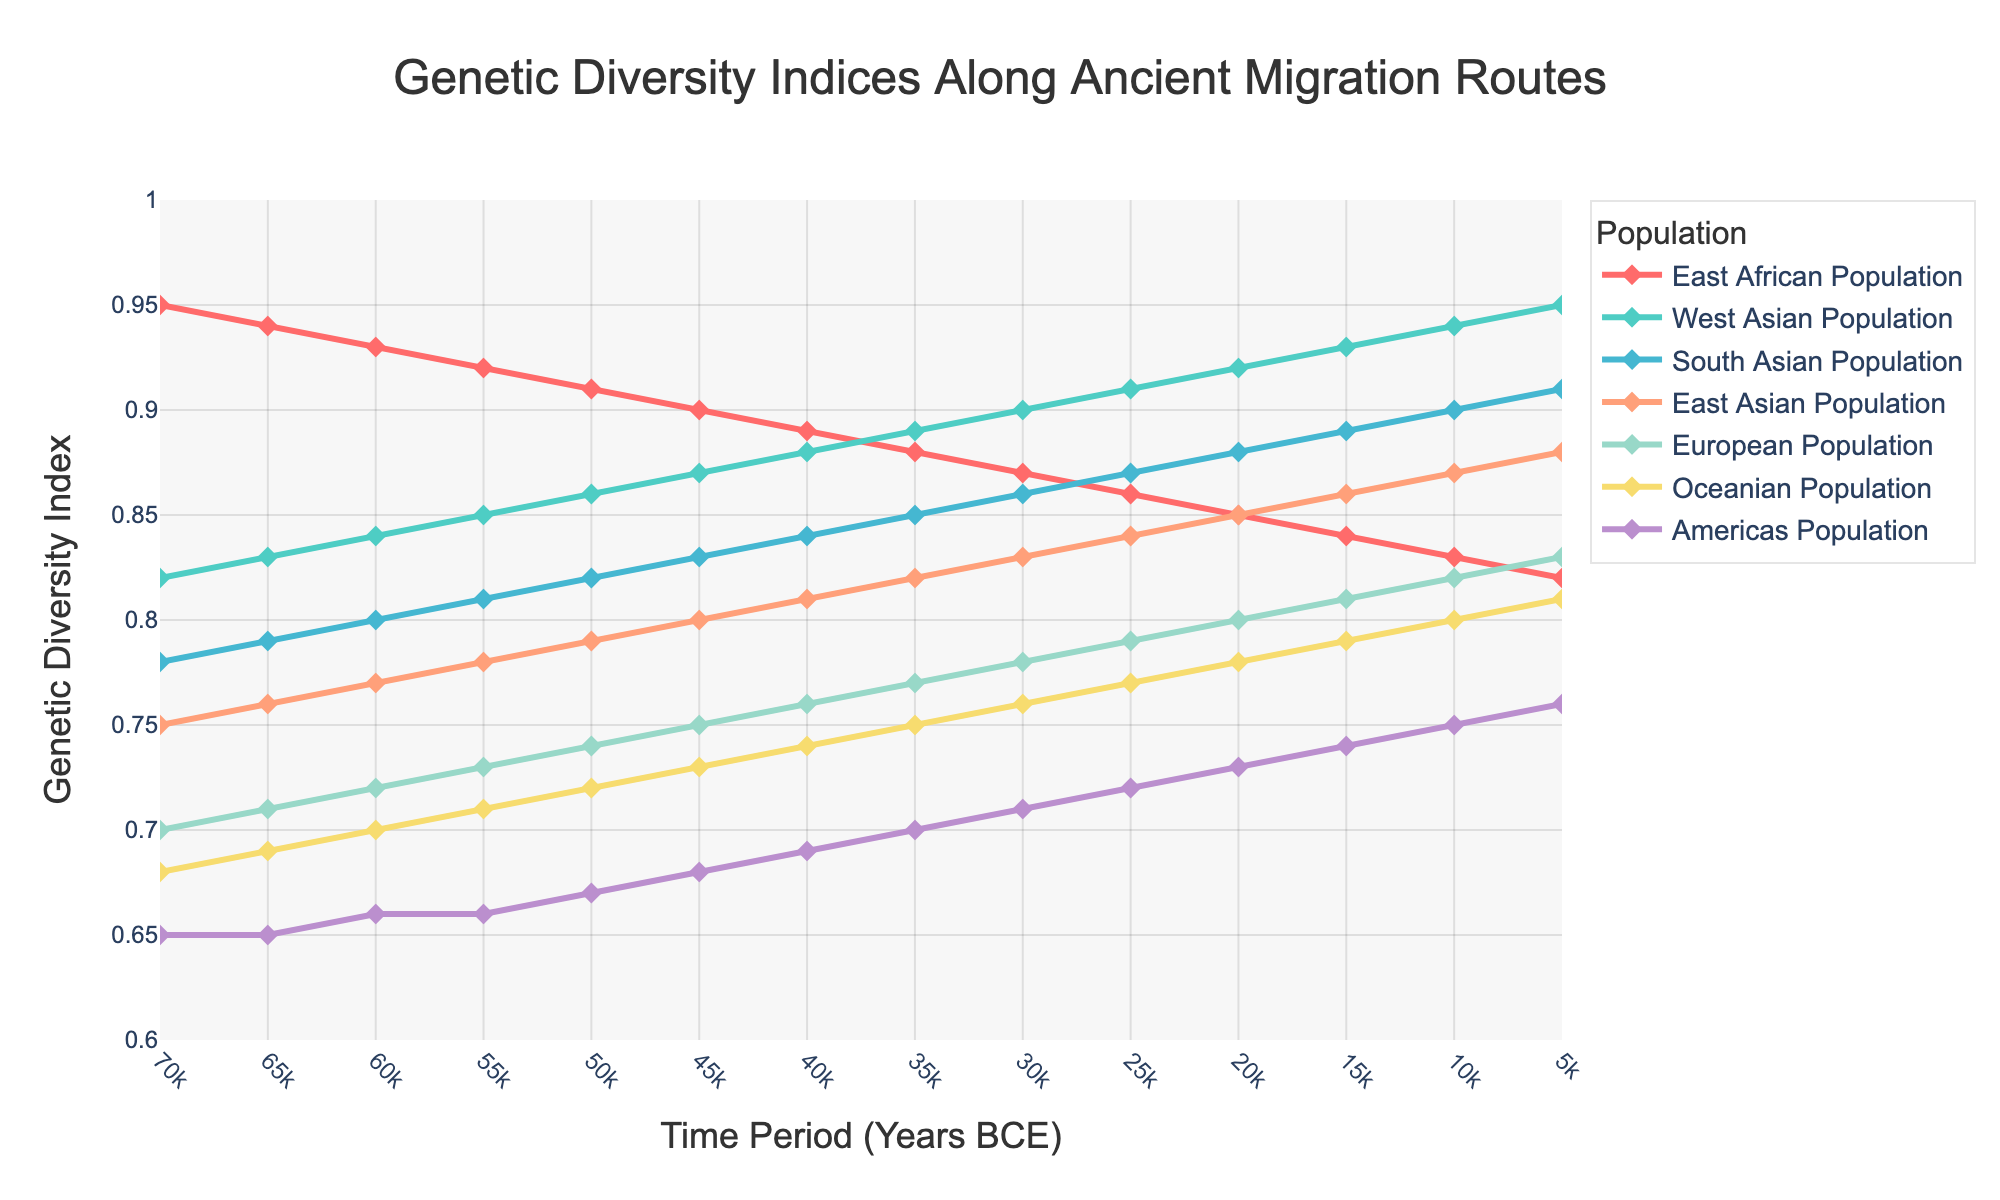Which population had the highest genetic diversity in 5,000 BCE? The East African Population shows the highest Genetic Diversity Index of 0.91 in the year 5,000 BCE.
Answer: East African Population How did the genetic diversity index of the European Population change from 70,000 BCE to 5,000 BCE? The Genetic Diversity Index of the European Population increased from 0.70 in 70,000 BCE to 0.83 in 5,000 BCE.
Answer: Increased What is the average genetic diversity index of the Oceanian Population over the entire time period? Sum the indices over all time periods (0.68+0.69+0.70+0.71+0.72+0.73+0.74+0.75+0.76+0.77+0.78+0.79+0.80+0.81) and divide by the number of time periods (14). Average = (0.68+0.69+0.70+0.71+0.72+0.73+0.74+0.75+0.76+0.77+0.78+0.79+0.80+0.81) / 14 = 0.74
Answer: 0.74 Which population experienced the smallest increase in genetic diversity from 70,000 BCE to 5,000 BCE? The Americas Population increased from 0.65 to 0.76, an increase of 0.11, which is the smallest among all populations.
Answer: Americas Population By how much did the genetic diversity index of the East Asian Population increase during the time period from 20,000 BCE to 15,000 BCE? The genetic diversity index of the East Asian Population increased from 0.85 to 0.86, a change of 0.01.
Answer: 0.01 Which population shows a steady increase in genetic diversity from 70,000 BCE to 5,000 BCE? The genetic diversity indices of the East African Population show a consistent decline rather than an increase. West Asian, South Asian, East Asian, European, Oceanian, and the Americas Populations show steady increases.
Answer: West Asian, South Asian, East Asian, European, Oceanian, and Americas Populations Compare the genetic diversity indices of East Asian and European Populations at several key time points (70,000 BCE, 50,000 BCE, and 10,000 BCE). At 70,000 BCE, East Asian: 0.75, European: 0.70. At 50,000 BCE, East Asian: 0.79, European: 0.74. At 10,000 BCE, East Asian: 0.87, European: 0.82. In all instances, the East Asian Population had higher indices.
Answer: East Asian Population always had higher indices Which two populations had almost identical genetic diversity indices around 40,000 BCE? The genetic diversity indices of the West Asian Population (0.88) and the South Asian Population (0.84) show the closest values but are not identical. No populations share almost identical values at exactly 40,000 BCE. Only these two, West Asian and South Asian, are the closest.
Answer: West Asian and South Asian Populations During which time period did the East African Population experience the most rapid decrease in genetic diversity index? From 60,000 BCE to 50,000 BCE, the genetic diversity index of the East African Population decreased from 0.93 to 0.91, a decrease of 0.02, the most rapid decline compared to other periods.
Answer: From 60,000 BCE to 50,000 BCE 